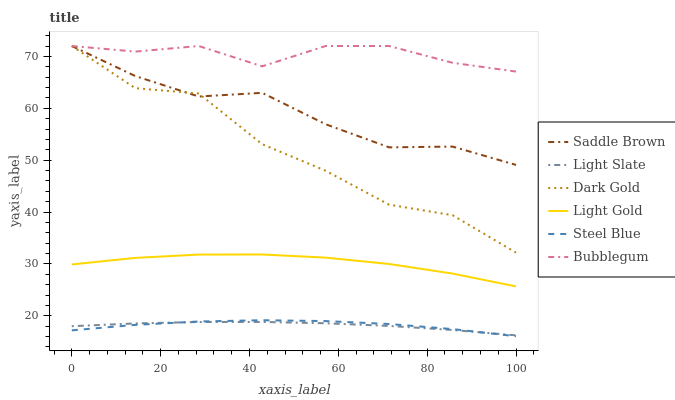Does Light Slate have the minimum area under the curve?
Answer yes or no. Yes. Does Bubblegum have the maximum area under the curve?
Answer yes or no. Yes. Does Steel Blue have the minimum area under the curve?
Answer yes or no. No. Does Steel Blue have the maximum area under the curve?
Answer yes or no. No. Is Light Slate the smoothest?
Answer yes or no. Yes. Is Dark Gold the roughest?
Answer yes or no. Yes. Is Steel Blue the smoothest?
Answer yes or no. No. Is Steel Blue the roughest?
Answer yes or no. No. Does Steel Blue have the lowest value?
Answer yes or no. Yes. Does Light Slate have the lowest value?
Answer yes or no. No. Does Saddle Brown have the highest value?
Answer yes or no. Yes. Does Steel Blue have the highest value?
Answer yes or no. No. Is Light Slate less than Dark Gold?
Answer yes or no. Yes. Is Light Gold greater than Light Slate?
Answer yes or no. Yes. Does Dark Gold intersect Saddle Brown?
Answer yes or no. Yes. Is Dark Gold less than Saddle Brown?
Answer yes or no. No. Is Dark Gold greater than Saddle Brown?
Answer yes or no. No. Does Light Slate intersect Dark Gold?
Answer yes or no. No. 